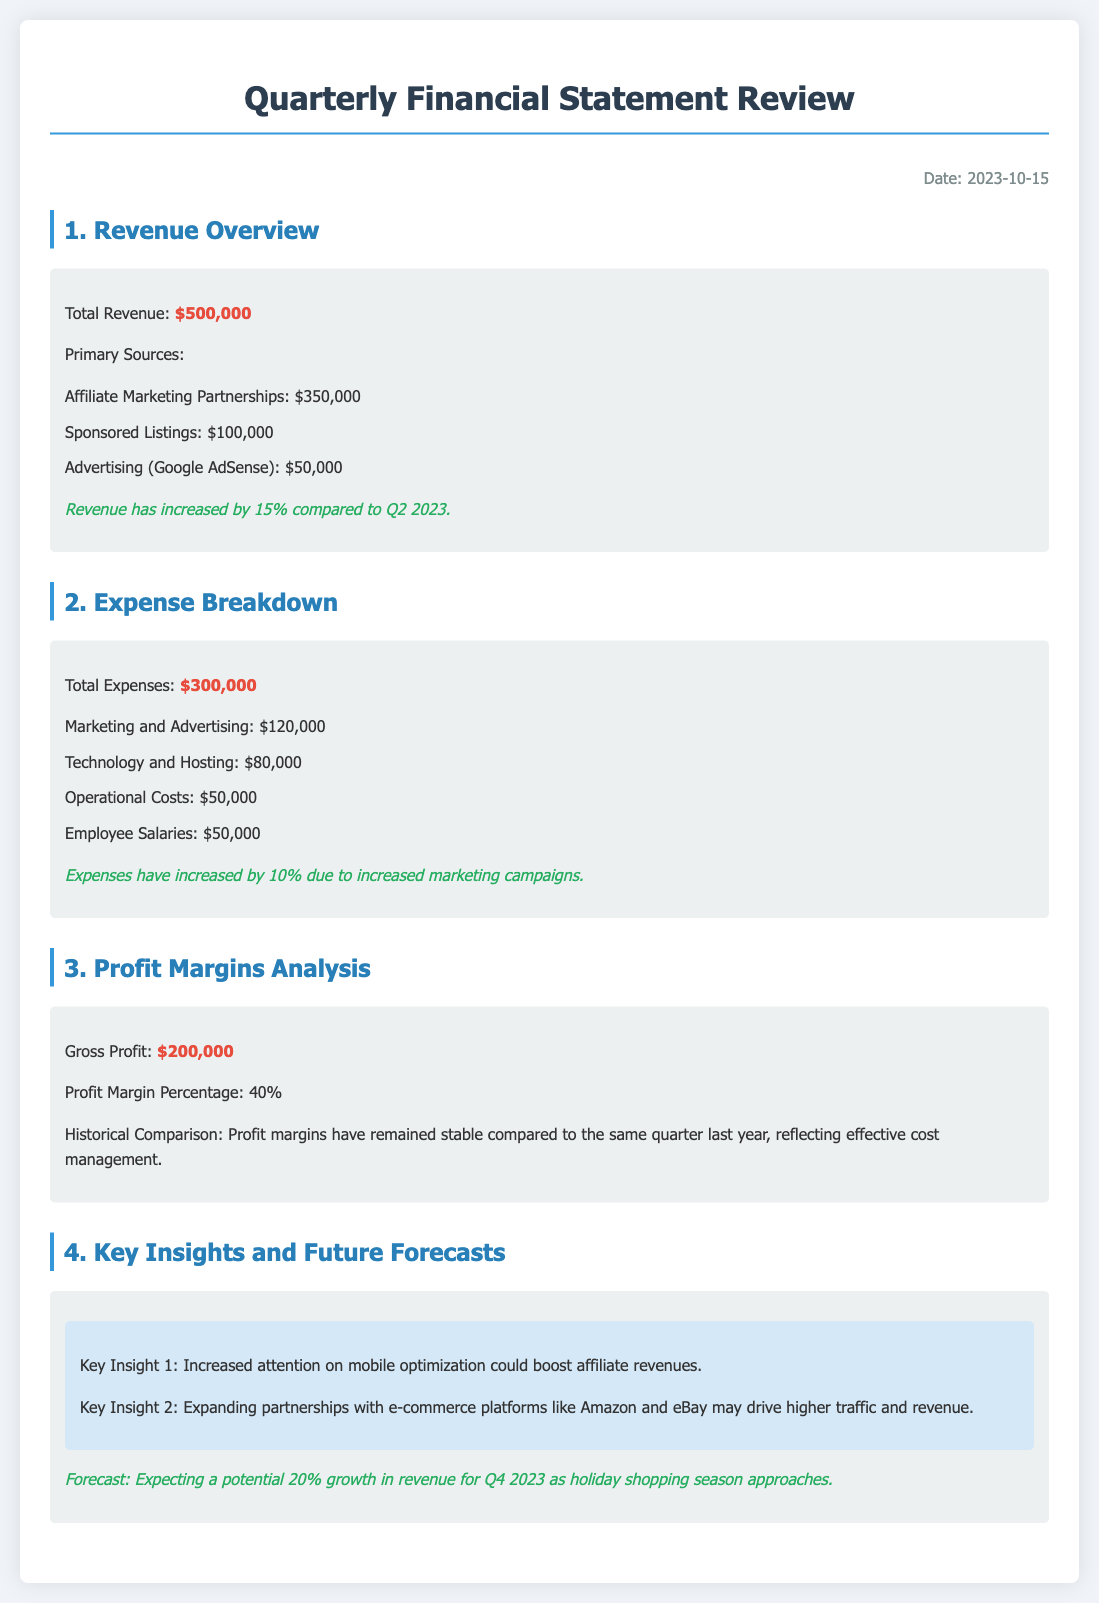What is the total revenue? The total revenue is presented in the document, summarizing all revenue sources, which is $500,000.
Answer: $500,000 How much did affiliate marketing partnerships contribute to revenue? The document specifies the contribution of affiliate marketing partnerships to total revenue, which is $350,000.
Answer: $350,000 What is the total expenses amount? The document lists total expenses, which accounts for all expenses summarized, totaling $300,000.
Answer: $300,000 How much has the revenue increased compared to Q2 2023? The document provides information on the percentage increase in revenue from the previous quarter, which is 15%.
Answer: 15% What is the gross profit amount? The gross profit calculated in the document is clearly stated, totaling $200,000.
Answer: $200,000 What is the profit margin percentage? The document highlights the profit margin percentage, which is stated as 40%.
Answer: 40% What are key insights regarding mobile optimization? The document mentions significant insights, one being that increased attention on mobile optimization could enhance affiliate revenues.
Answer: Increased attention on mobile optimization What is the expected revenue growth percentage for Q4 2023? The document forecasts the revenue growth for the upcoming quarter, which is expected to be 20%.
Answer: 20% What caused the expenses to increase by 10%? The document explicitly states that expenses have increased due to heightened marketing campaigns.
Answer: Increased marketing campaigns 